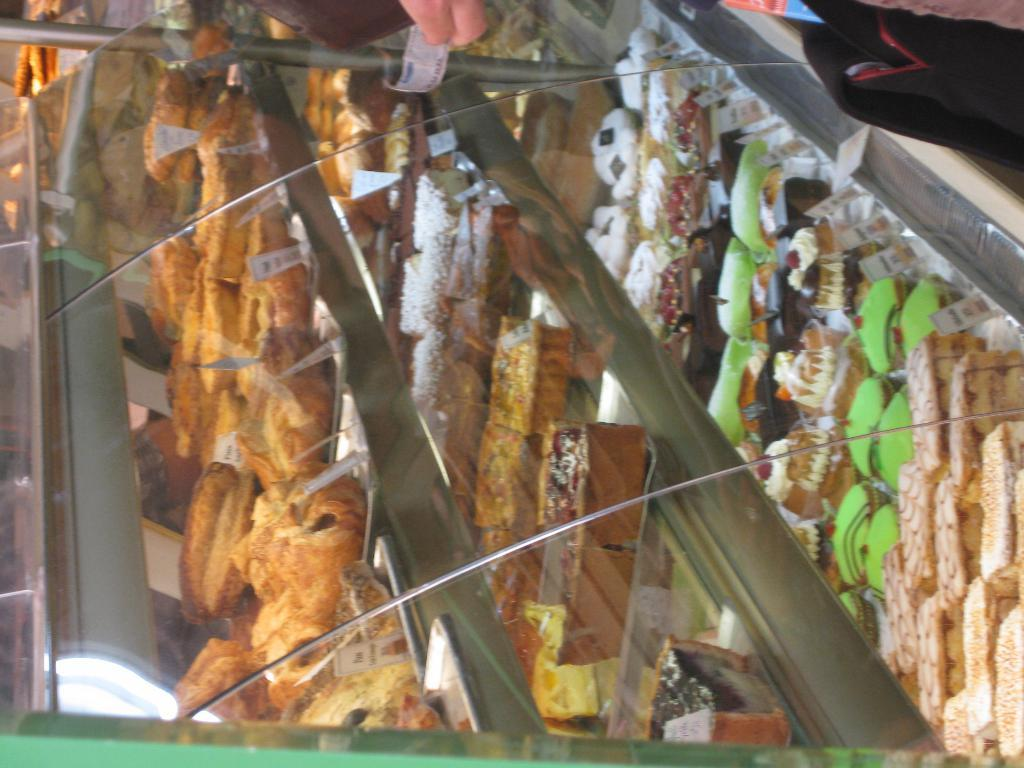What type of shelf is visible in the image? There is a glass shelf in the image. What can be found on the glass shelf? There are food items on the glass shelf. How far away is the toothpaste from the glass shelf in the image? There is no toothpaste present in the image, so it cannot be determined how far away it might be. 